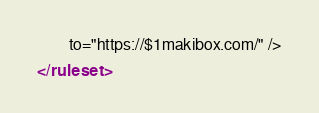<code> <loc_0><loc_0><loc_500><loc_500><_XML_>		to="https://$1makibox.com/" />

</ruleset></code> 